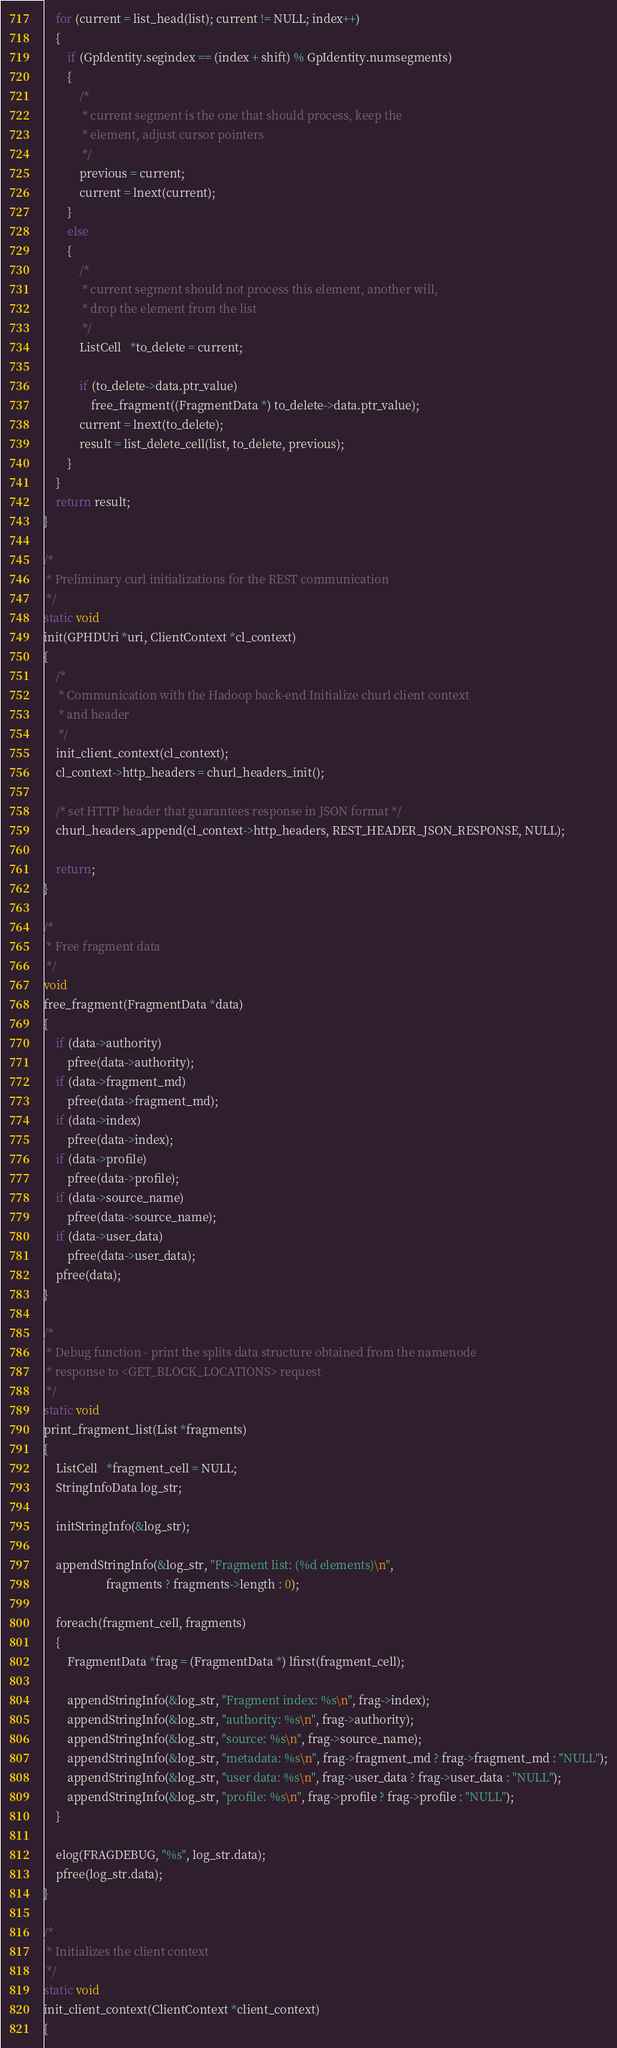Convert code to text. <code><loc_0><loc_0><loc_500><loc_500><_C_>	for (current = list_head(list); current != NULL; index++)
	{
		if (GpIdentity.segindex == (index + shift) % GpIdentity.numsegments)
		{
			/*
			 * current segment is the one that should process, keep the
			 * element, adjust cursor pointers
			 */
			previous = current;
			current = lnext(current);
		}
		else
		{
			/*
			 * current segment should not process this element, another will,
			 * drop the element from the list
			 */
			ListCell   *to_delete = current;

			if (to_delete->data.ptr_value)
				free_fragment((FragmentData *) to_delete->data.ptr_value);
			current = lnext(to_delete);
			result = list_delete_cell(list, to_delete, previous);
		}
	}
	return result;
}

/*
 * Preliminary curl initializations for the REST communication
 */
static void
init(GPHDUri *uri, ClientContext *cl_context)
{
	/*
	 * Communication with the Hadoop back-end Initialize churl client context
	 * and header
	 */
	init_client_context(cl_context);
	cl_context->http_headers = churl_headers_init();

	/* set HTTP header that guarantees response in JSON format */
	churl_headers_append(cl_context->http_headers, REST_HEADER_JSON_RESPONSE, NULL);

	return;
}

/*
 * Free fragment data
 */
void
free_fragment(FragmentData *data)
{
	if (data->authority)
		pfree(data->authority);
	if (data->fragment_md)
		pfree(data->fragment_md);
	if (data->index)
		pfree(data->index);
	if (data->profile)
		pfree(data->profile);
	if (data->source_name)
		pfree(data->source_name);
	if (data->user_data)
		pfree(data->user_data);
	pfree(data);
}

/*
 * Debug function - print the splits data structure obtained from the namenode
 * response to <GET_BLOCK_LOCATIONS> request
 */
static void
print_fragment_list(List *fragments)
{
	ListCell   *fragment_cell = NULL;
	StringInfoData log_str;

	initStringInfo(&log_str);

	appendStringInfo(&log_str, "Fragment list: (%d elements)\n",
					 fragments ? fragments->length : 0);

	foreach(fragment_cell, fragments)
	{
		FragmentData *frag = (FragmentData *) lfirst(fragment_cell);

		appendStringInfo(&log_str, "Fragment index: %s\n", frag->index);
		appendStringInfo(&log_str, "authority: %s\n", frag->authority);
		appendStringInfo(&log_str, "source: %s\n", frag->source_name);
		appendStringInfo(&log_str, "metadata: %s\n", frag->fragment_md ? frag->fragment_md : "NULL");
		appendStringInfo(&log_str, "user data: %s\n", frag->user_data ? frag->user_data : "NULL");
		appendStringInfo(&log_str, "profile: %s\n", frag->profile ? frag->profile : "NULL");
	}

	elog(FRAGDEBUG, "%s", log_str.data);
	pfree(log_str.data);
}

/*
 * Initializes the client context
 */
static void
init_client_context(ClientContext *client_context)
{</code> 